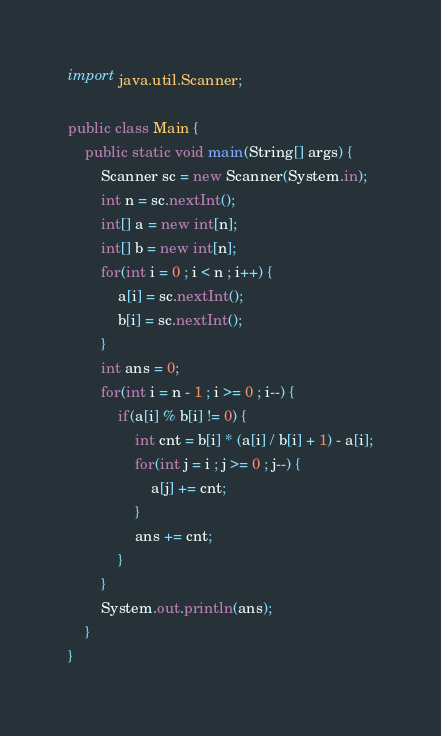<code> <loc_0><loc_0><loc_500><loc_500><_Java_>import java.util.Scanner;

public class Main {
	public static void main(String[] args) {
		Scanner sc = new Scanner(System.in);
		int n = sc.nextInt();
		int[] a = new int[n];
		int[] b = new int[n];
		for(int i = 0 ; i < n ; i++) {
			a[i] = sc.nextInt();
			b[i] = sc.nextInt();
		}
		int ans = 0;
		for(int i = n - 1 ; i >= 0 ; i--) {
			if(a[i] % b[i] != 0) {
				int cnt = b[i] * (a[i] / b[i] + 1) - a[i];
				for(int j = i ; j >= 0 ; j--) {
					a[j] += cnt;
				}
				ans += cnt;
			}
		}
		System.out.println(ans);
	}
}
</code> 